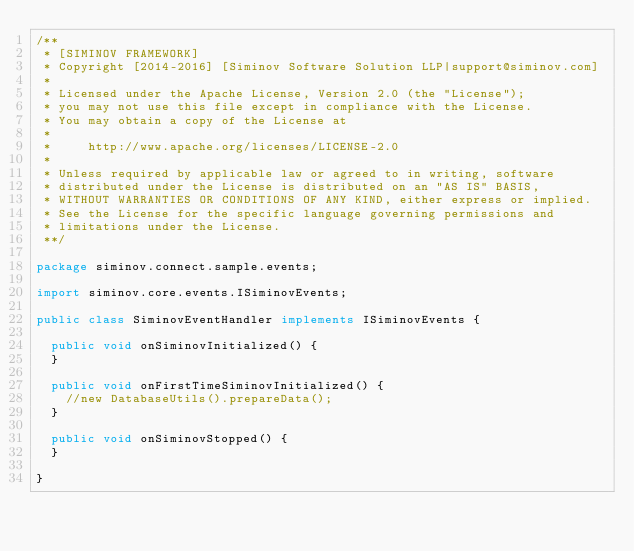Convert code to text. <code><loc_0><loc_0><loc_500><loc_500><_Java_>/**
 * [SIMINOV FRAMEWORK]
 * Copyright [2014-2016] [Siminov Software Solution LLP|support@siminov.com]
 *
 * Licensed under the Apache License, Version 2.0 (the "License");
 * you may not use this file except in compliance with the License.
 * You may obtain a copy of the License at
 *
 *     http://www.apache.org/licenses/LICENSE-2.0
 *
 * Unless required by applicable law or agreed to in writing, software
 * distributed under the License is distributed on an "AS IS" BASIS,
 * WITHOUT WARRANTIES OR CONDITIONS OF ANY KIND, either express or implied.
 * See the License for the specific language governing permissions and
 * limitations under the License.
 **/

package siminov.connect.sample.events;

import siminov.core.events.ISiminovEvents;

public class SiminovEventHandler implements ISiminovEvents {

	public void onSiminovInitialized() {
	}

	public void onFirstTimeSiminovInitialized() {
		//new DatabaseUtils().prepareData();
	}

	public void onSiminovStopped() {
	}

}
</code> 